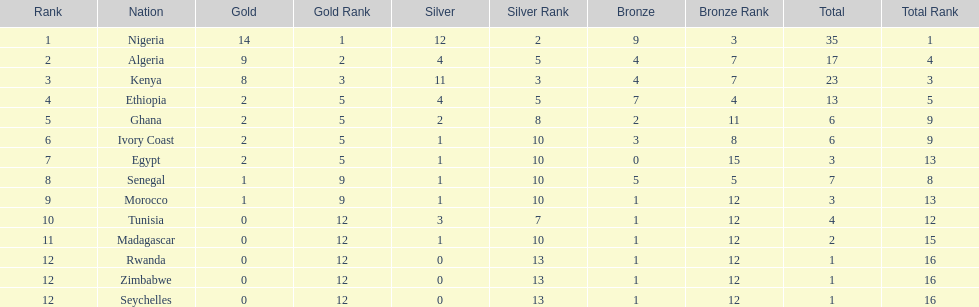The country that won the most medals was? Nigeria. 